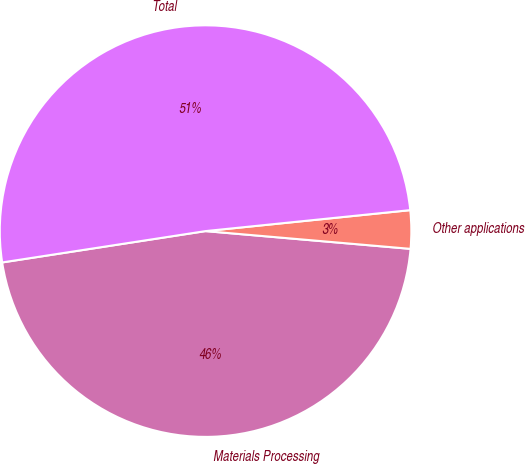Convert chart. <chart><loc_0><loc_0><loc_500><loc_500><pie_chart><fcel>Materials Processing<fcel>Other applications<fcel>Total<nl><fcel>46.19%<fcel>3.0%<fcel>50.81%<nl></chart> 